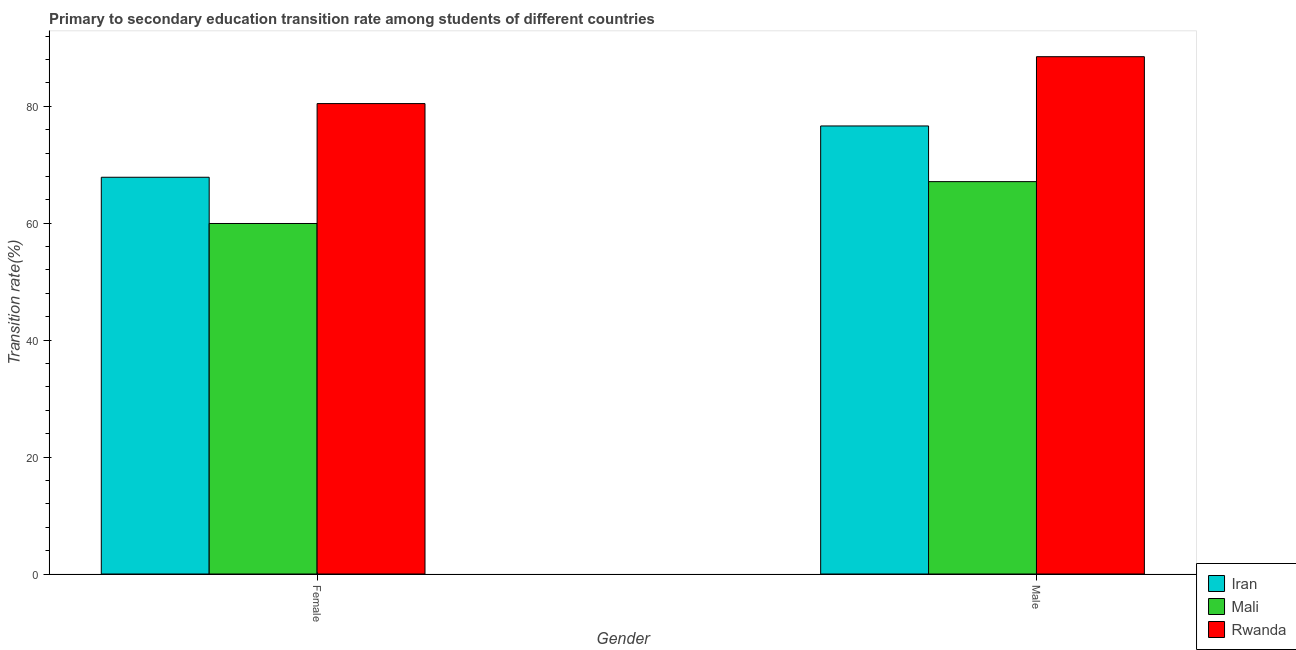How many different coloured bars are there?
Give a very brief answer. 3. How many groups of bars are there?
Keep it short and to the point. 2. Are the number of bars per tick equal to the number of legend labels?
Offer a terse response. Yes. Are the number of bars on each tick of the X-axis equal?
Your answer should be very brief. Yes. How many bars are there on the 1st tick from the left?
Give a very brief answer. 3. What is the transition rate among female students in Iran?
Offer a very short reply. 67.85. Across all countries, what is the maximum transition rate among female students?
Ensure brevity in your answer.  80.45. Across all countries, what is the minimum transition rate among male students?
Provide a short and direct response. 67.11. In which country was the transition rate among female students maximum?
Give a very brief answer. Rwanda. In which country was the transition rate among male students minimum?
Offer a very short reply. Mali. What is the total transition rate among male students in the graph?
Your answer should be compact. 232.21. What is the difference between the transition rate among male students in Rwanda and that in Iran?
Provide a succinct answer. 11.85. What is the difference between the transition rate among male students in Rwanda and the transition rate among female students in Mali?
Provide a short and direct response. 28.53. What is the average transition rate among female students per country?
Make the answer very short. 69.42. What is the difference between the transition rate among female students and transition rate among male students in Iran?
Your answer should be compact. -8.77. What is the ratio of the transition rate among male students in Rwanda to that in Iran?
Give a very brief answer. 1.15. What does the 1st bar from the left in Female represents?
Your answer should be very brief. Iran. What does the 1st bar from the right in Female represents?
Keep it short and to the point. Rwanda. How many bars are there?
Give a very brief answer. 6. Are all the bars in the graph horizontal?
Your response must be concise. No. Are the values on the major ticks of Y-axis written in scientific E-notation?
Provide a short and direct response. No. Does the graph contain any zero values?
Keep it short and to the point. No. How many legend labels are there?
Your response must be concise. 3. How are the legend labels stacked?
Offer a very short reply. Vertical. What is the title of the graph?
Give a very brief answer. Primary to secondary education transition rate among students of different countries. Does "Bermuda" appear as one of the legend labels in the graph?
Give a very brief answer. No. What is the label or title of the X-axis?
Your answer should be compact. Gender. What is the label or title of the Y-axis?
Your answer should be very brief. Transition rate(%). What is the Transition rate(%) in Iran in Female?
Give a very brief answer. 67.85. What is the Transition rate(%) of Mali in Female?
Your answer should be compact. 59.95. What is the Transition rate(%) of Rwanda in Female?
Provide a short and direct response. 80.45. What is the Transition rate(%) of Iran in Male?
Provide a succinct answer. 76.63. What is the Transition rate(%) of Mali in Male?
Provide a succinct answer. 67.11. What is the Transition rate(%) of Rwanda in Male?
Your answer should be compact. 88.47. Across all Gender, what is the maximum Transition rate(%) of Iran?
Your answer should be very brief. 76.63. Across all Gender, what is the maximum Transition rate(%) in Mali?
Your answer should be very brief. 67.11. Across all Gender, what is the maximum Transition rate(%) of Rwanda?
Your answer should be very brief. 88.47. Across all Gender, what is the minimum Transition rate(%) of Iran?
Provide a short and direct response. 67.85. Across all Gender, what is the minimum Transition rate(%) of Mali?
Your response must be concise. 59.95. Across all Gender, what is the minimum Transition rate(%) in Rwanda?
Your answer should be very brief. 80.45. What is the total Transition rate(%) of Iran in the graph?
Offer a very short reply. 144.48. What is the total Transition rate(%) of Mali in the graph?
Your answer should be very brief. 127.05. What is the total Transition rate(%) in Rwanda in the graph?
Make the answer very short. 168.93. What is the difference between the Transition rate(%) of Iran in Female and that in Male?
Ensure brevity in your answer.  -8.77. What is the difference between the Transition rate(%) in Mali in Female and that in Male?
Provide a short and direct response. -7.16. What is the difference between the Transition rate(%) of Rwanda in Female and that in Male?
Offer a very short reply. -8.02. What is the difference between the Transition rate(%) of Iran in Female and the Transition rate(%) of Mali in Male?
Offer a terse response. 0.75. What is the difference between the Transition rate(%) in Iran in Female and the Transition rate(%) in Rwanda in Male?
Make the answer very short. -20.62. What is the difference between the Transition rate(%) of Mali in Female and the Transition rate(%) of Rwanda in Male?
Make the answer very short. -28.53. What is the average Transition rate(%) of Iran per Gender?
Provide a short and direct response. 72.24. What is the average Transition rate(%) in Mali per Gender?
Your answer should be very brief. 63.53. What is the average Transition rate(%) in Rwanda per Gender?
Give a very brief answer. 84.46. What is the difference between the Transition rate(%) in Iran and Transition rate(%) in Mali in Female?
Provide a short and direct response. 7.91. What is the difference between the Transition rate(%) in Iran and Transition rate(%) in Rwanda in Female?
Provide a short and direct response. -12.6. What is the difference between the Transition rate(%) of Mali and Transition rate(%) of Rwanda in Female?
Make the answer very short. -20.51. What is the difference between the Transition rate(%) in Iran and Transition rate(%) in Mali in Male?
Ensure brevity in your answer.  9.52. What is the difference between the Transition rate(%) of Iran and Transition rate(%) of Rwanda in Male?
Your response must be concise. -11.85. What is the difference between the Transition rate(%) in Mali and Transition rate(%) in Rwanda in Male?
Provide a succinct answer. -21.37. What is the ratio of the Transition rate(%) in Iran in Female to that in Male?
Keep it short and to the point. 0.89. What is the ratio of the Transition rate(%) in Mali in Female to that in Male?
Your answer should be compact. 0.89. What is the ratio of the Transition rate(%) in Rwanda in Female to that in Male?
Your answer should be very brief. 0.91. What is the difference between the highest and the second highest Transition rate(%) of Iran?
Make the answer very short. 8.77. What is the difference between the highest and the second highest Transition rate(%) of Mali?
Keep it short and to the point. 7.16. What is the difference between the highest and the second highest Transition rate(%) of Rwanda?
Offer a terse response. 8.02. What is the difference between the highest and the lowest Transition rate(%) in Iran?
Keep it short and to the point. 8.77. What is the difference between the highest and the lowest Transition rate(%) in Mali?
Make the answer very short. 7.16. What is the difference between the highest and the lowest Transition rate(%) of Rwanda?
Your answer should be very brief. 8.02. 